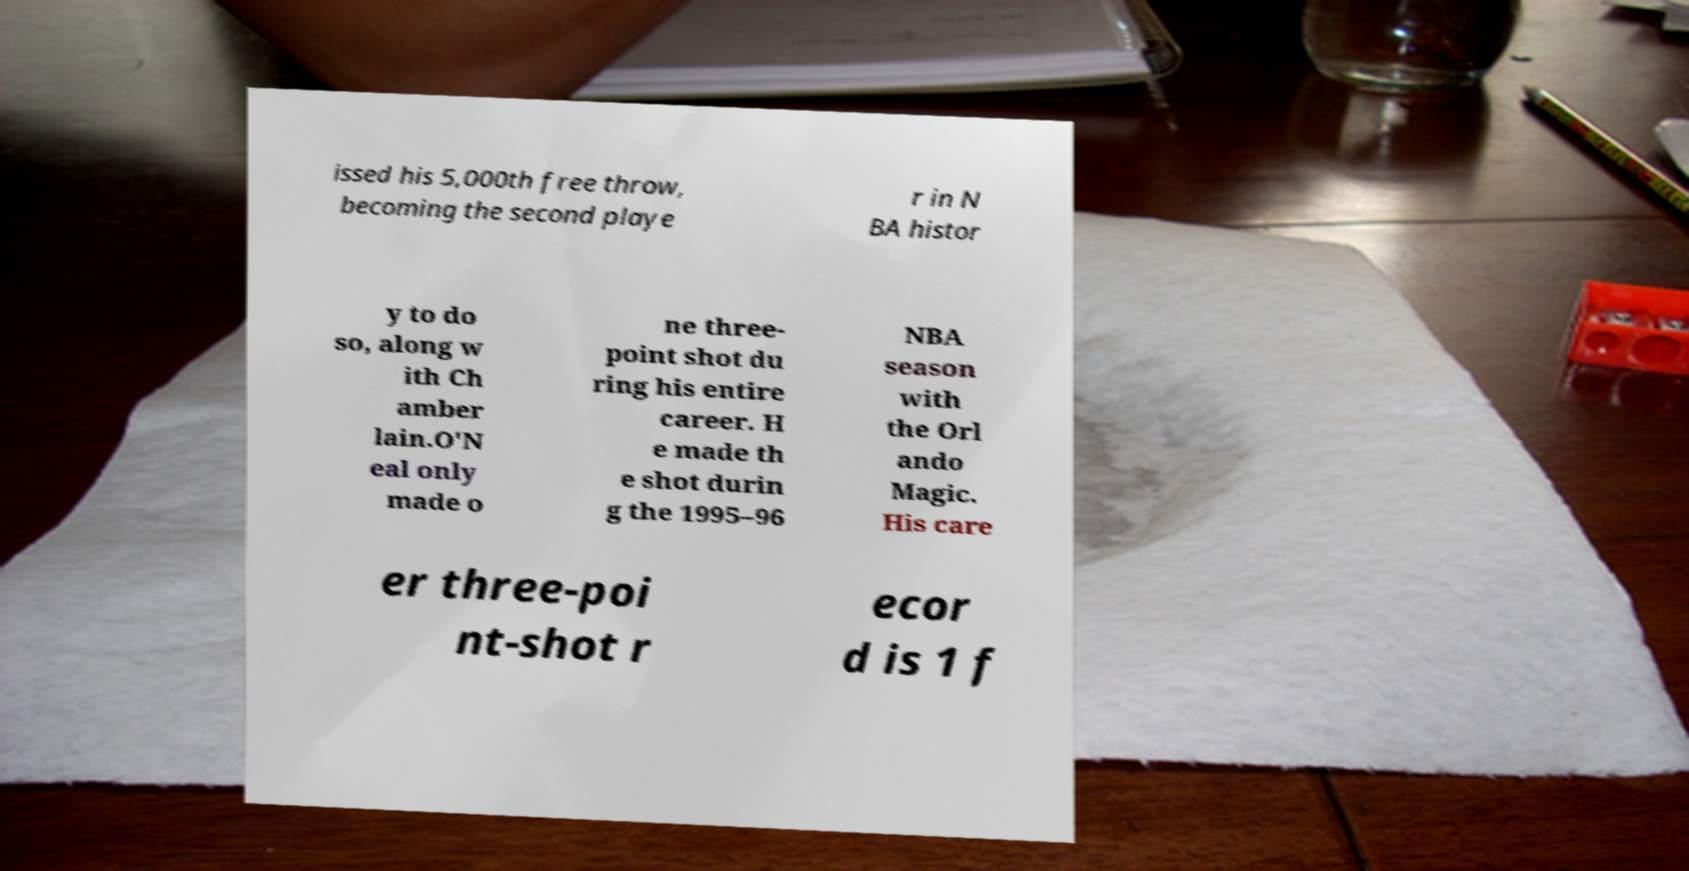For documentation purposes, I need the text within this image transcribed. Could you provide that? issed his 5,000th free throw, becoming the second playe r in N BA histor y to do so, along w ith Ch amber lain.O'N eal only made o ne three- point shot du ring his entire career. H e made th e shot durin g the 1995–96 NBA season with the Orl ando Magic. His care er three-poi nt-shot r ecor d is 1 f 